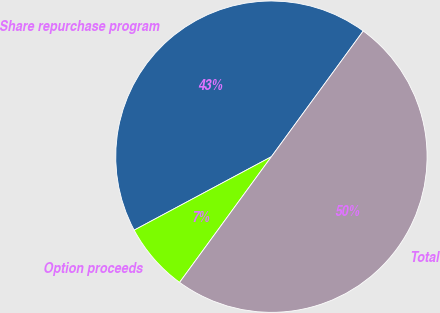Convert chart to OTSL. <chart><loc_0><loc_0><loc_500><loc_500><pie_chart><fcel>Share repurchase program<fcel>Option proceeds<fcel>Total<nl><fcel>42.86%<fcel>7.14%<fcel>50.0%<nl></chart> 